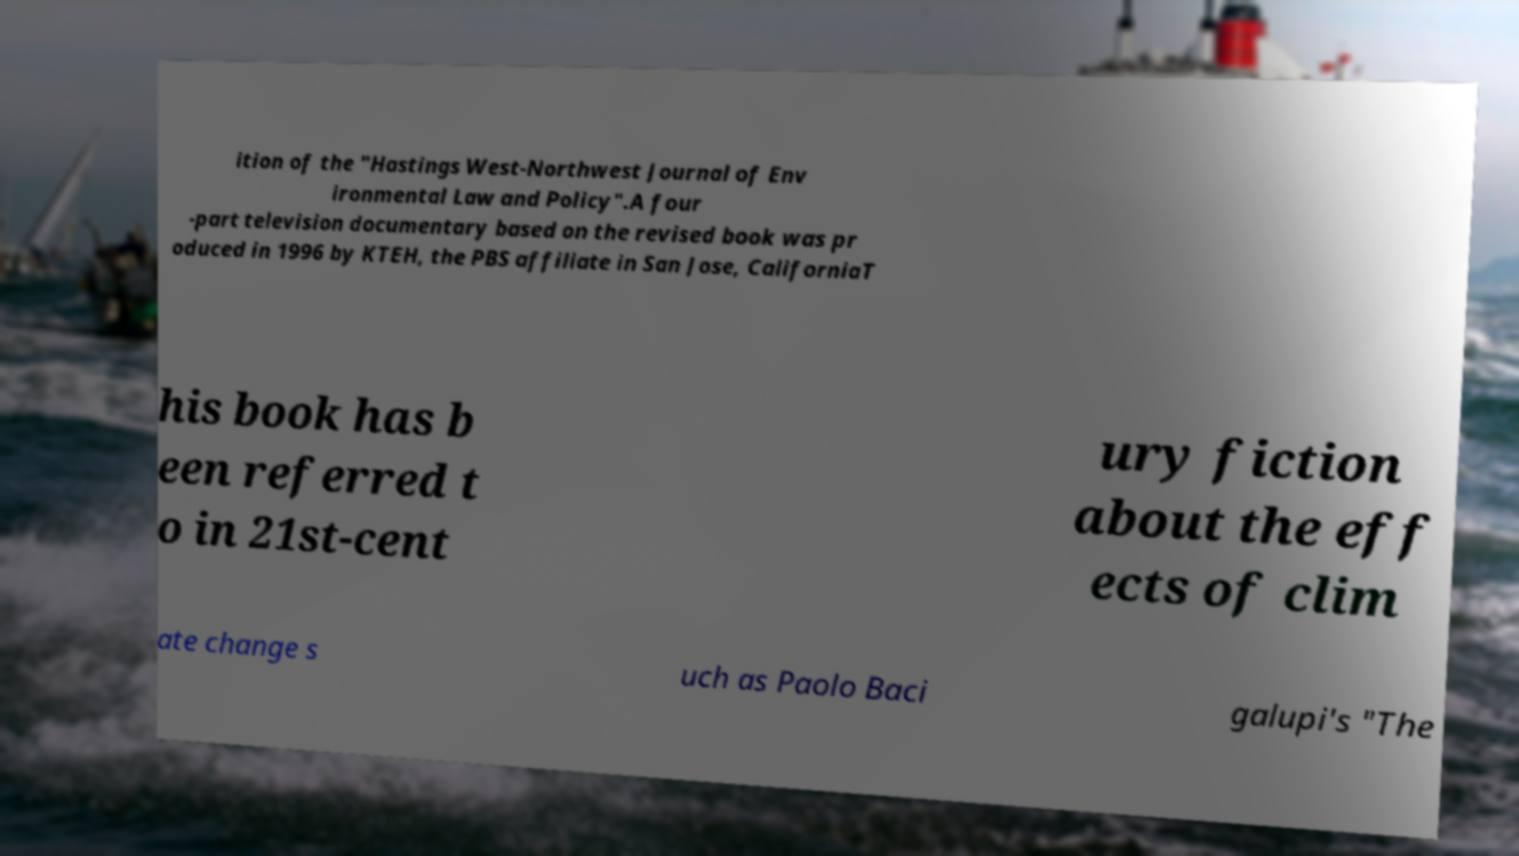What messages or text are displayed in this image? I need them in a readable, typed format. ition of the "Hastings West-Northwest Journal of Env ironmental Law and Policy".A four -part television documentary based on the revised book was pr oduced in 1996 by KTEH, the PBS affiliate in San Jose, CaliforniaT his book has b een referred t o in 21st-cent ury fiction about the eff ects of clim ate change s uch as Paolo Baci galupi's "The 